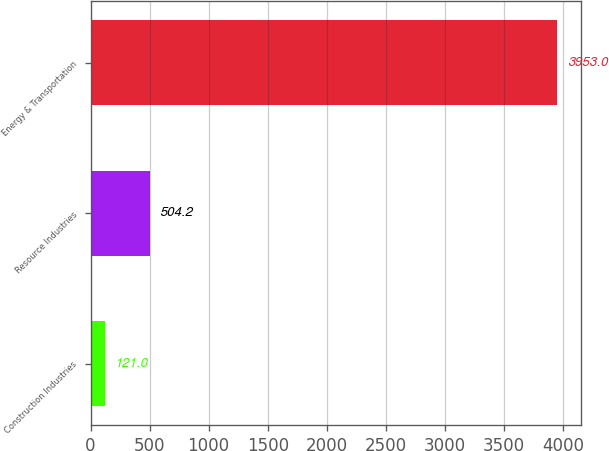Convert chart. <chart><loc_0><loc_0><loc_500><loc_500><bar_chart><fcel>Construction Industries<fcel>Resource Industries<fcel>Energy & Transportation<nl><fcel>121<fcel>504.2<fcel>3953<nl></chart> 